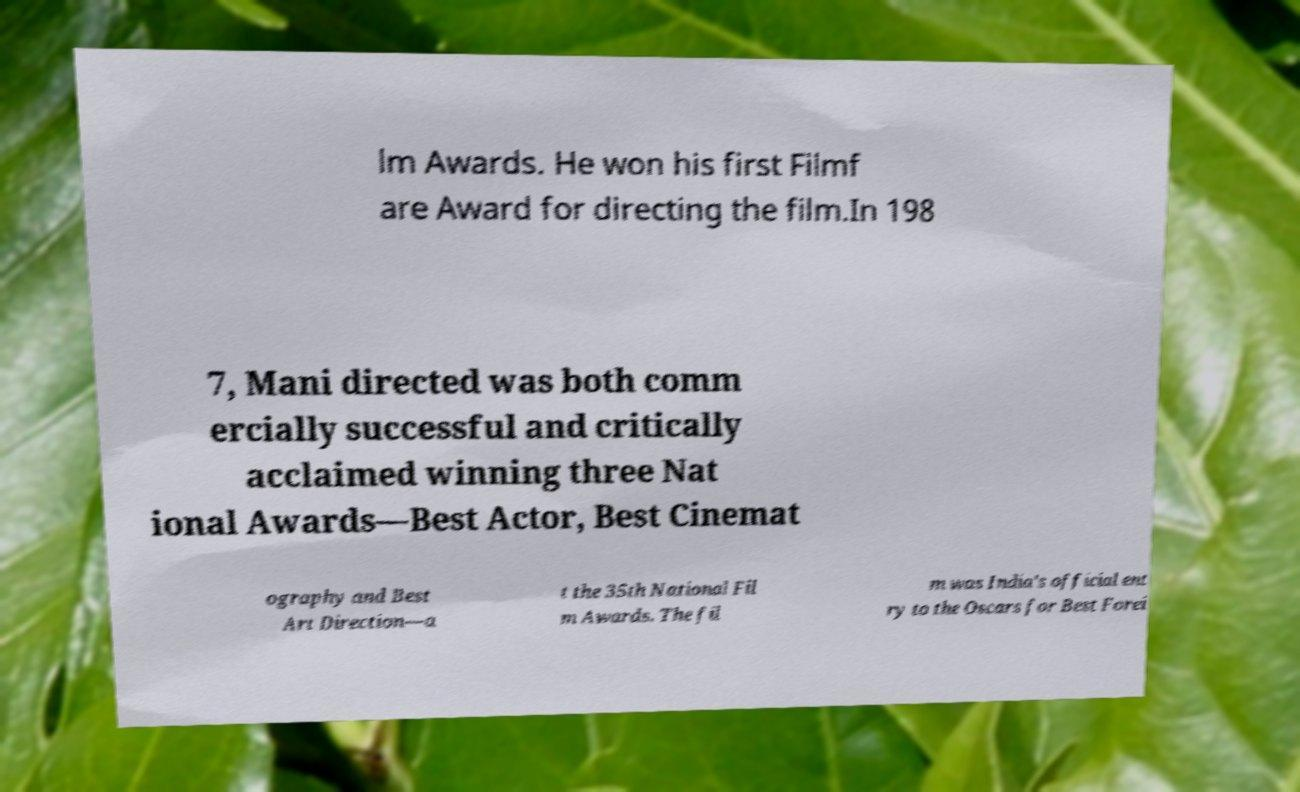Please read and relay the text visible in this image. What does it say? lm Awards. He won his first Filmf are Award for directing the film.In 198 7, Mani directed was both comm ercially successful and critically acclaimed winning three Nat ional Awards—Best Actor, Best Cinemat ography and Best Art Direction—a t the 35th National Fil m Awards. The fil m was India's official ent ry to the Oscars for Best Forei 